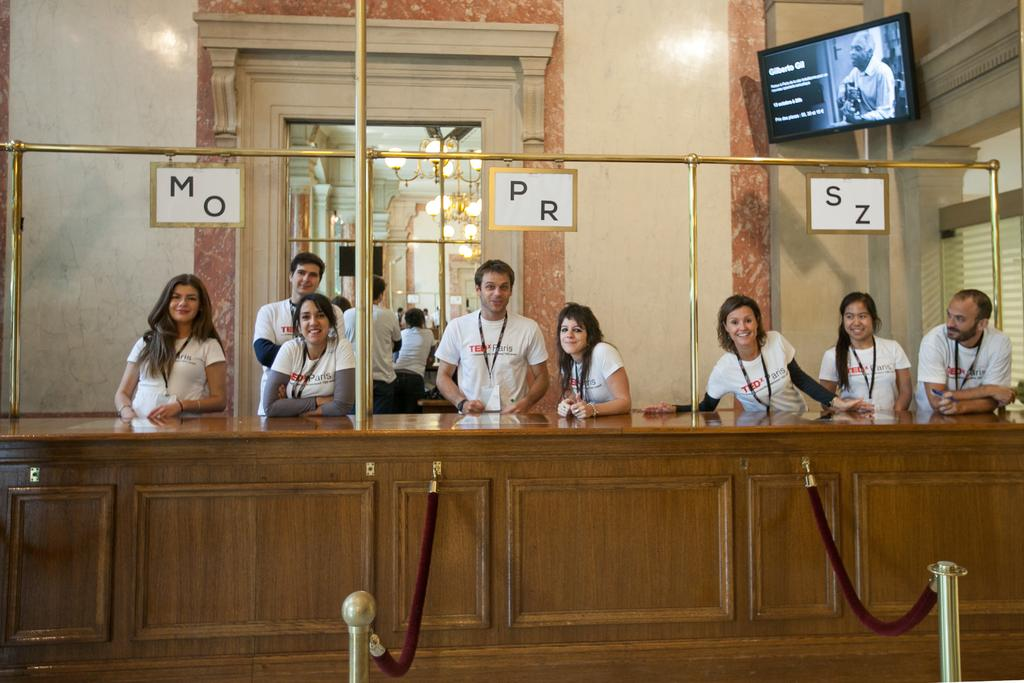How many persons can be seen in the image? There are persons standing in the image. What surface are the persons standing on? The persons are standing on the floor. What object is placed in front of the persons? There is a table placed in front of the persons. What architectural features can be seen in the background of the image? There are chandeliers, walls, and name boards visible in the background of the image. What electronic device is visible in the background of the image? A display screen is visible in the background of the image. What type of map is being used by the persons to teach in the image? There is no map present in the image, and the persons are not depicted as teaching. 